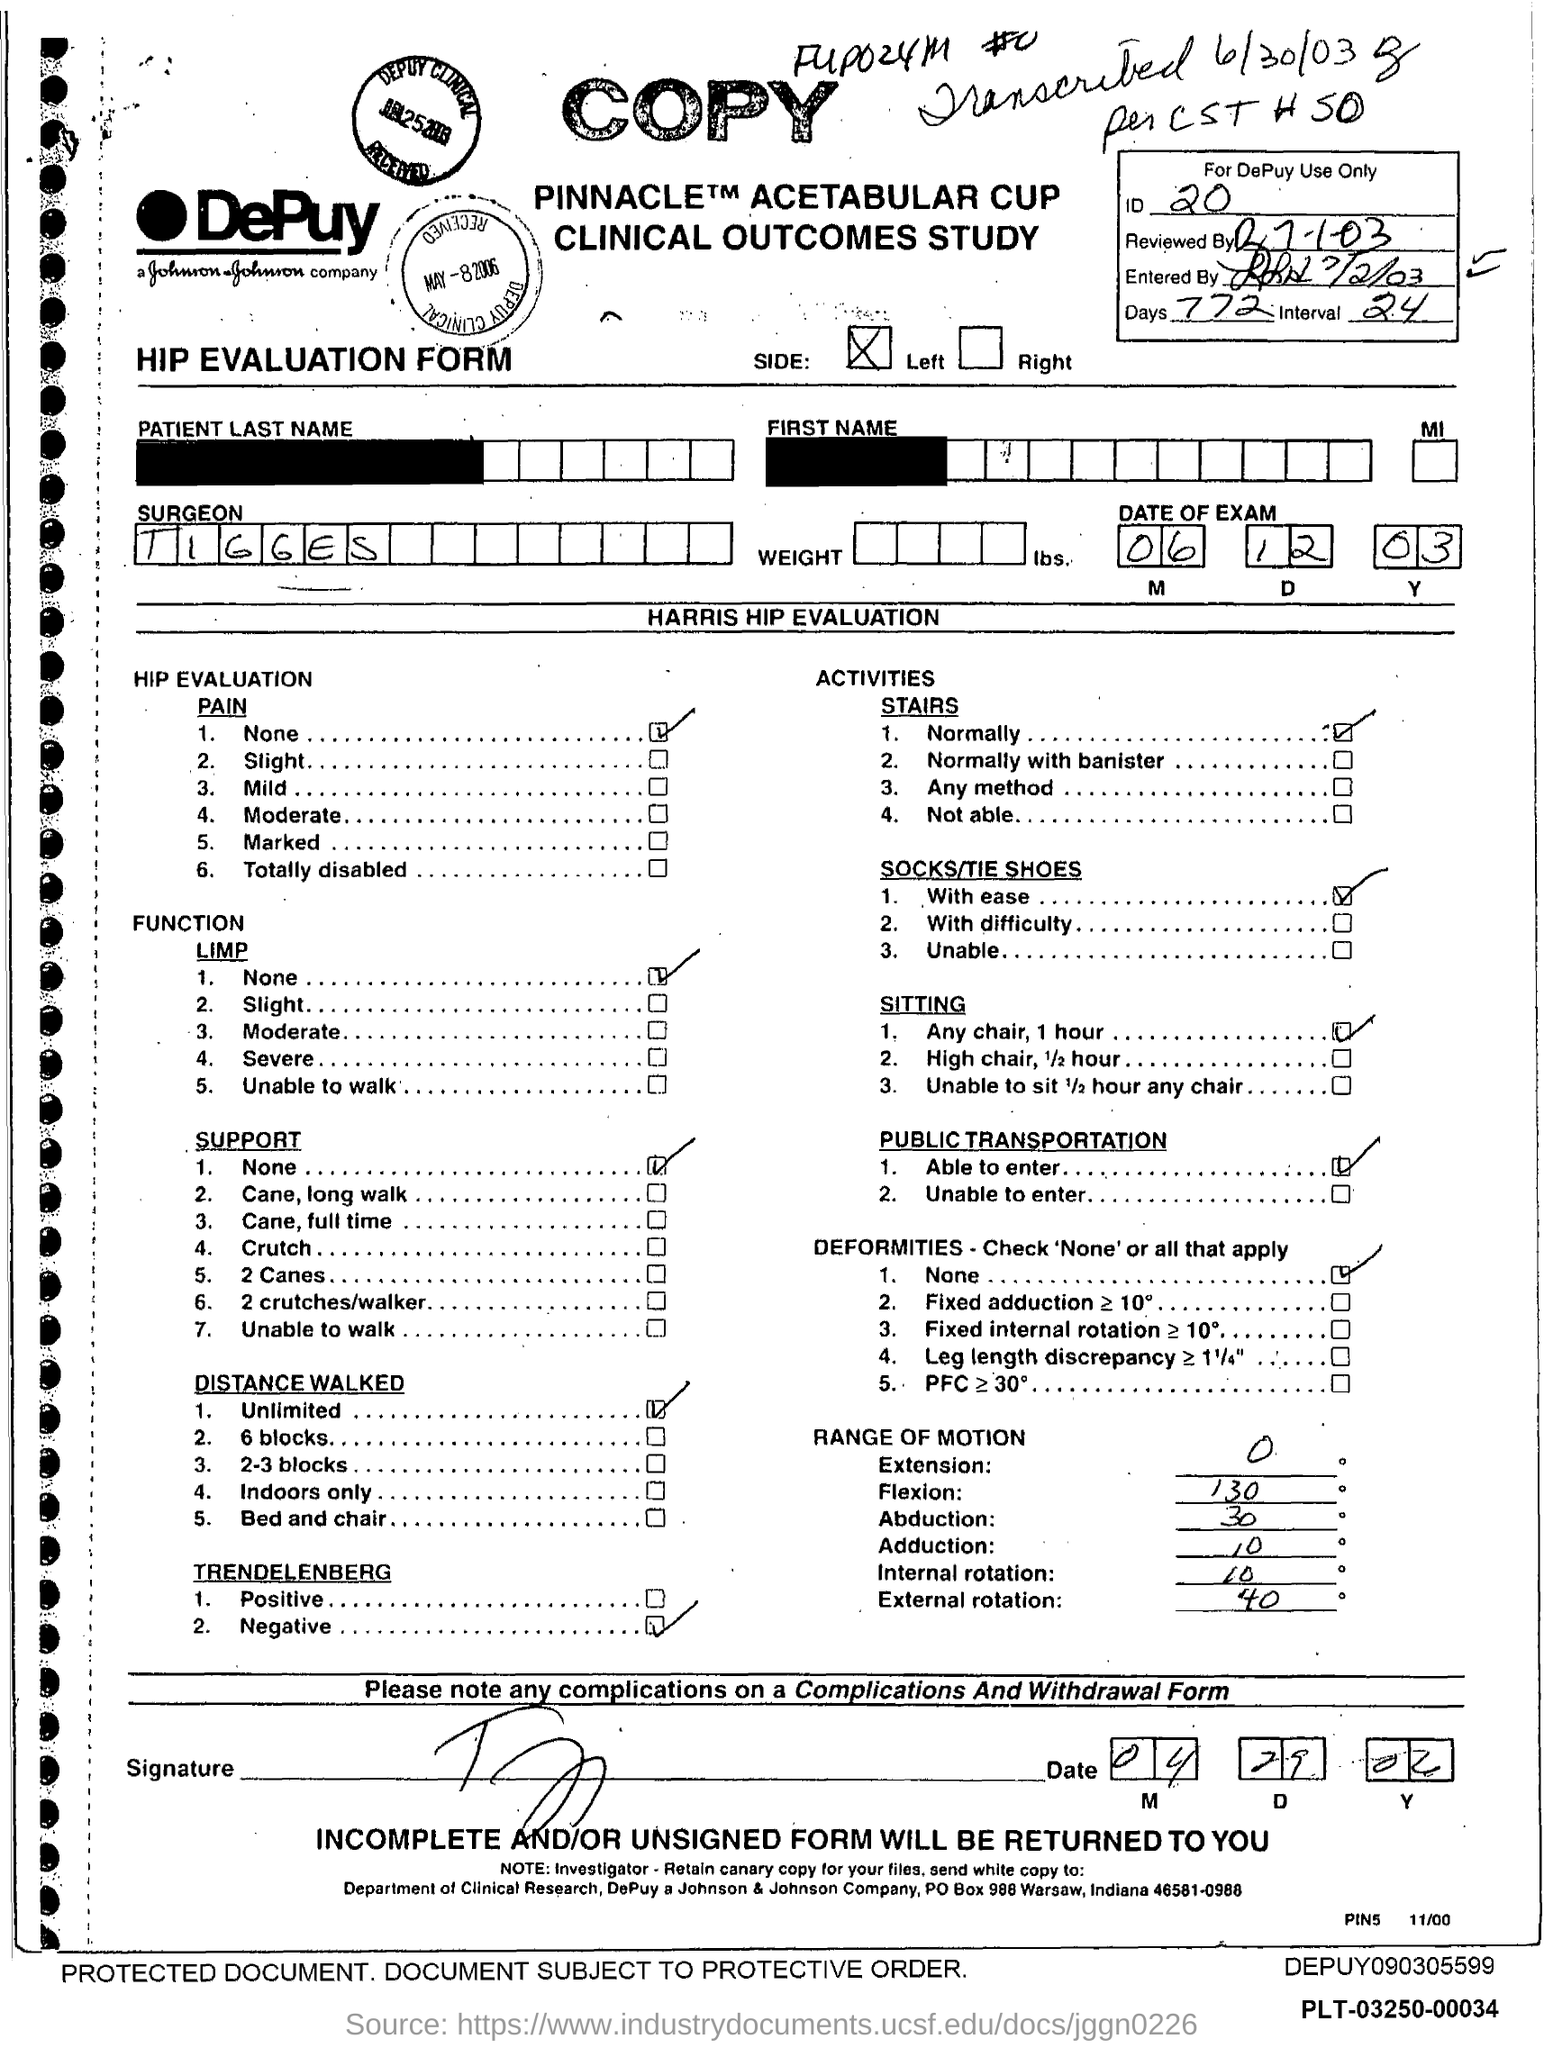What is the ID mentioned in the form?
Provide a succinct answer. 20. What type of form is given here?
Your response must be concise. HIP EVALUATION FORM. What is the surgeon's name mentioned in the form?
Offer a terse response. TIGGES. What is the date of the exam given in the form?
Provide a short and direct response. 06 12 03. What is the no of days given in the form?
Give a very brief answer. 772. What is the interval mentioned in the form?
Your response must be concise. 24. 